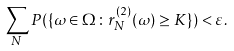<formula> <loc_0><loc_0><loc_500><loc_500>\sum _ { N } P ( \{ \omega \in \Omega \colon r _ { N } ^ { ( 2 ) } ( \omega ) \geq K \} ) < \varepsilon .</formula> 